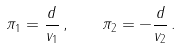Convert formula to latex. <formula><loc_0><loc_0><loc_500><loc_500>\pi _ { 1 } = \frac { d } { v _ { 1 } } \, , \quad \pi _ { 2 } = - \frac { d } { v _ { 2 } } \, .</formula> 